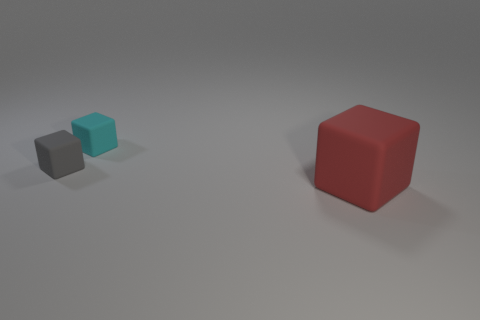What size is the gray rubber thing that is the same shape as the big red matte object?
Keep it short and to the point. Small. The tiny thing that is behind the rubber block left of the tiny rubber cube that is behind the tiny gray cube is made of what material?
Make the answer very short. Rubber. Are any red objects visible?
Keep it short and to the point. Yes. There is a big matte cube; is its color the same as the tiny matte object on the right side of the small gray object?
Provide a short and direct response. No. What is the color of the big object?
Your answer should be very brief. Red. Are there any other things that have the same shape as the large red thing?
Give a very brief answer. Yes. The other big object that is the same shape as the gray matte object is what color?
Make the answer very short. Red. Is the red rubber object the same shape as the small gray rubber thing?
Your response must be concise. Yes. How many balls are small cyan objects or tiny gray things?
Offer a very short reply. 0. There is a large object that is made of the same material as the small cyan thing; what color is it?
Your response must be concise. Red. 